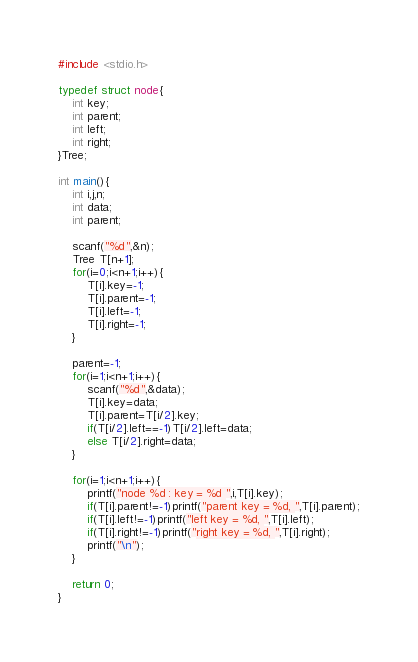Convert code to text. <code><loc_0><loc_0><loc_500><loc_500><_C_>#include <stdio.h>

typedef struct node{
    int key;
    int parent;
    int left;
    int right;
}Tree;

int main(){
    int i,j,n;
    int data;
    int parent;
    
    scanf("%d",&n);
    Tree T[n+1];
    for(i=0;i<n+1;i++){
        T[i].key=-1;
        T[i].parent=-1;
        T[i].left=-1;
        T[i].right=-1;
    }
    
    parent=-1;
    for(i=1;i<n+1;i++){
        scanf("%d",&data);
        T[i].key=data;
        T[i].parent=T[i/2].key;
        if(T[i/2].left==-1)T[i/2].left=data;
        else T[i/2].right=data;
    }
    
    for(i=1;i<n+1;i++){
        printf("node %d : key = %d ",i,T[i].key);
        if(T[i].parent!=-1)printf("parent key = %d, ",T[i].parent);
        if(T[i].left!=-1)printf("left key = %d, ",T[i].left);
        if(T[i].right!=-1)printf("right key = %d, ",T[i].right);
        printf("\n");
    }
    
    return 0;
}</code> 